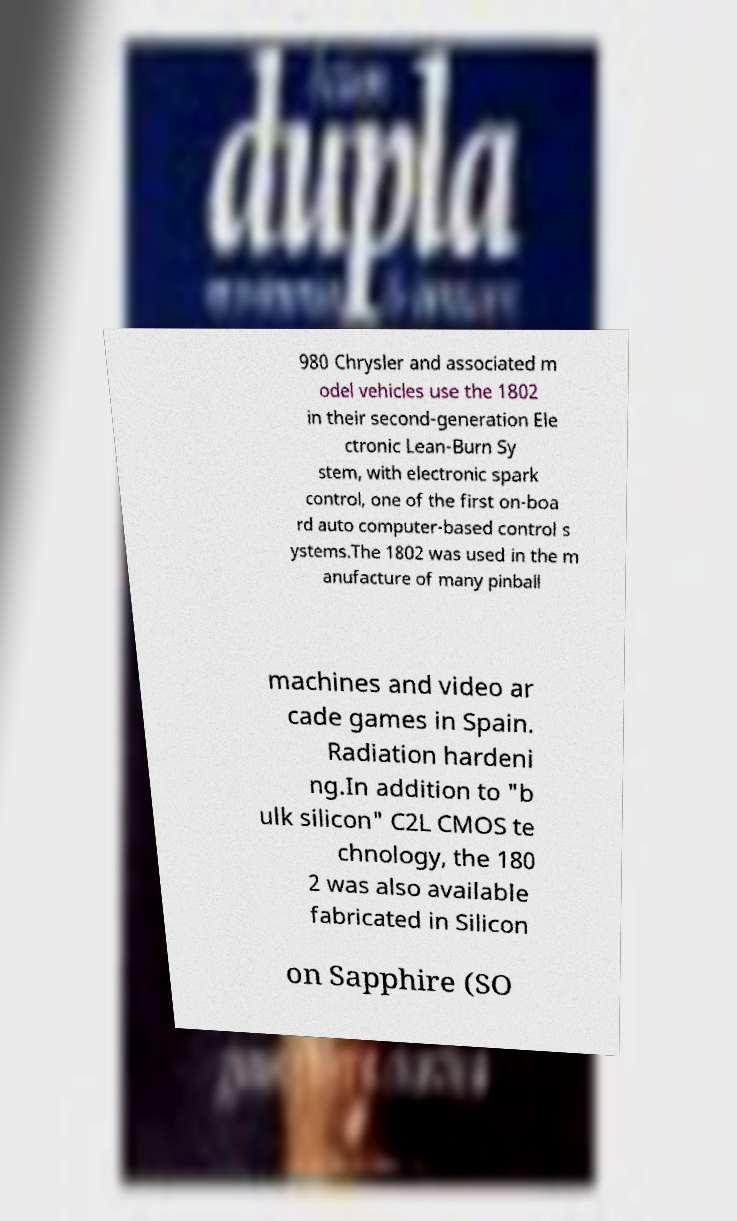What messages or text are displayed in this image? I need them in a readable, typed format. 980 Chrysler and associated m odel vehicles use the 1802 in their second-generation Ele ctronic Lean-Burn Sy stem, with electronic spark control, one of the first on-boa rd auto computer-based control s ystems.The 1802 was used in the m anufacture of many pinball machines and video ar cade games in Spain. Radiation hardeni ng.In addition to "b ulk silicon" C2L CMOS te chnology, the 180 2 was also available fabricated in Silicon on Sapphire (SO 